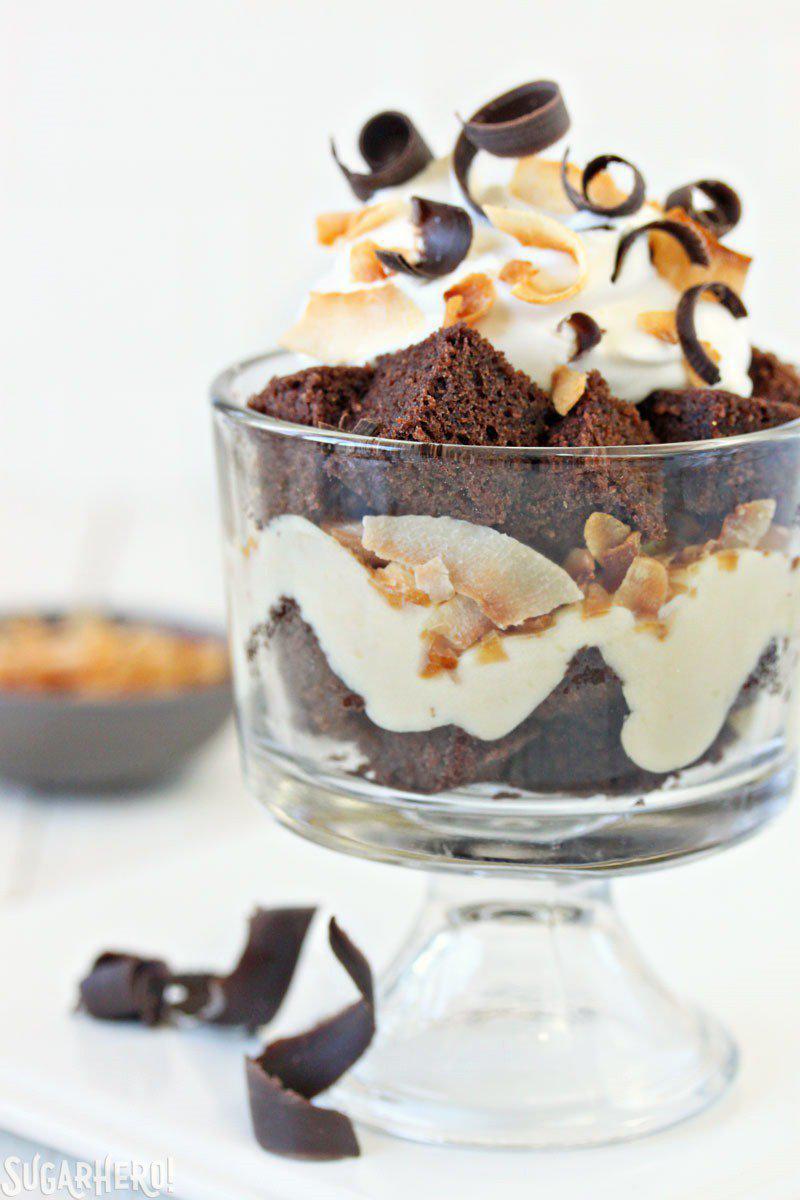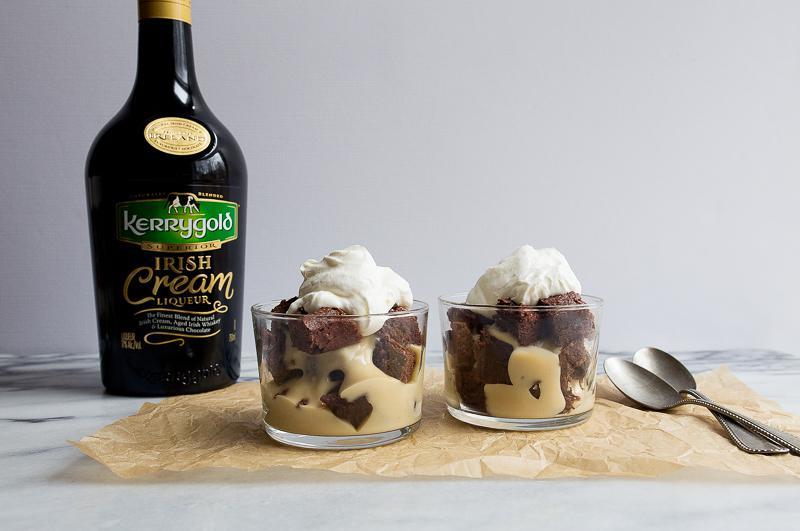The first image is the image on the left, the second image is the image on the right. Given the left and right images, does the statement "A bottle of irish cream sits near the desserts in one of the images." hold true? Answer yes or no. Yes. The first image is the image on the left, the second image is the image on the right. Examine the images to the left and right. Is the description "A bottle of liqueur is visible behind a creamy dessert with brown chunks in it." accurate? Answer yes or no. Yes. 